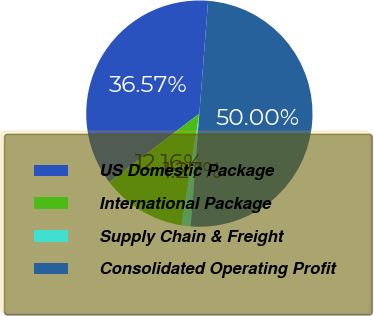Convert chart to OTSL. <chart><loc_0><loc_0><loc_500><loc_500><pie_chart><fcel>US Domestic Package<fcel>International Package<fcel>Supply Chain & Freight<fcel>Consolidated Operating Profit<nl><fcel>36.57%<fcel>12.16%<fcel>1.27%<fcel>50.0%<nl></chart> 